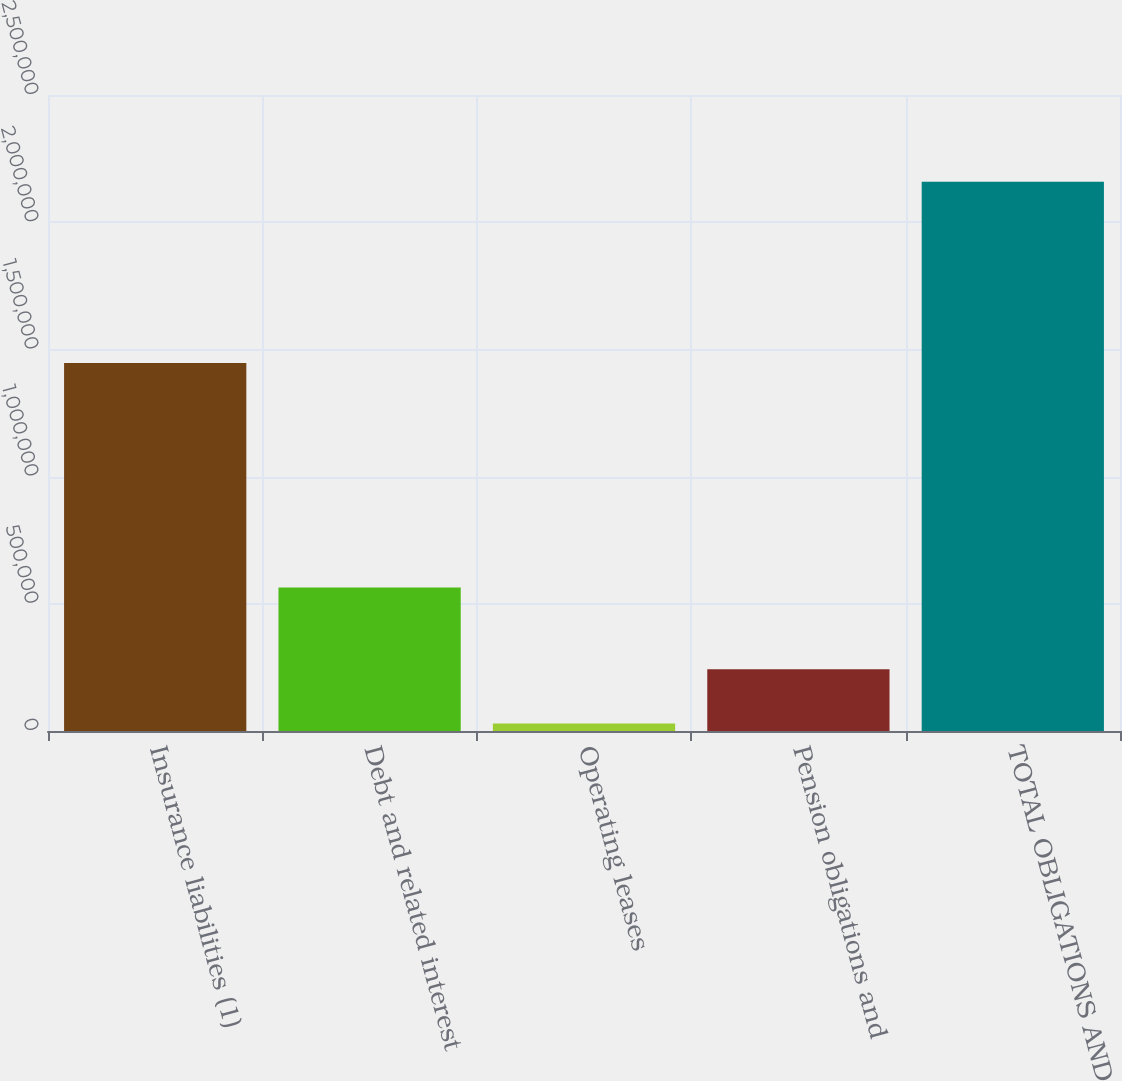Convert chart. <chart><loc_0><loc_0><loc_500><loc_500><bar_chart><fcel>Insurance liabilities (1)<fcel>Debt and related interest<fcel>Operating leases<fcel>Pension obligations and<fcel>TOTAL OBLIGATIONS AND<nl><fcel>1.44671e+06<fcel>564125<fcel>29349<fcel>242352<fcel>2.15937e+06<nl></chart> 